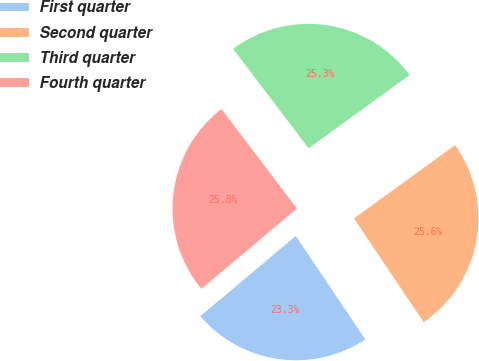Convert chart. <chart><loc_0><loc_0><loc_500><loc_500><pie_chart><fcel>First quarter<fcel>Second quarter<fcel>Third quarter<fcel>Fourth quarter<nl><fcel>23.28%<fcel>25.57%<fcel>25.34%<fcel>25.8%<nl></chart> 